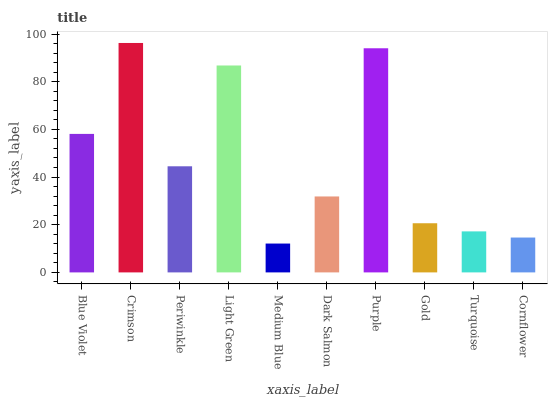Is Periwinkle the minimum?
Answer yes or no. No. Is Periwinkle the maximum?
Answer yes or no. No. Is Crimson greater than Periwinkle?
Answer yes or no. Yes. Is Periwinkle less than Crimson?
Answer yes or no. Yes. Is Periwinkle greater than Crimson?
Answer yes or no. No. Is Crimson less than Periwinkle?
Answer yes or no. No. Is Periwinkle the high median?
Answer yes or no. Yes. Is Dark Salmon the low median?
Answer yes or no. Yes. Is Blue Violet the high median?
Answer yes or no. No. Is Light Green the low median?
Answer yes or no. No. 